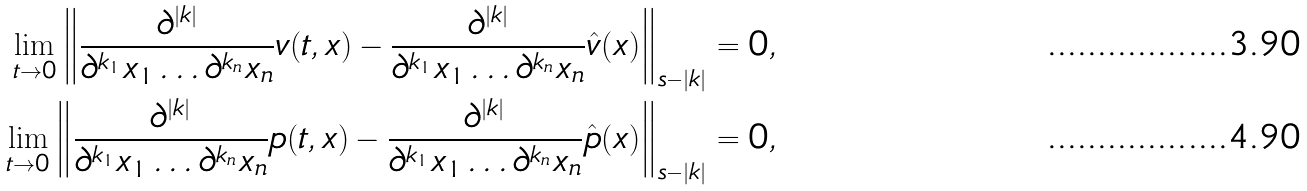Convert formula to latex. <formula><loc_0><loc_0><loc_500><loc_500>\lim _ { t \to 0 } \left \| \frac { \partial ^ { | k | } } { \partial ^ { k _ { 1 } } x _ { 1 } \dots \partial ^ { k _ { n } } x _ { n } } v ( t , x ) - \frac { \partial ^ { | k | } } { \partial ^ { k _ { 1 } } x _ { 1 } \dots \partial ^ { k _ { n } } x _ { n } } \hat { v } ( x ) \right \| _ { s - | k | } & = 0 , \\ \lim _ { t \to 0 } \left \| \frac { \partial ^ { | k | } } { \partial ^ { k _ { 1 } } x _ { 1 } \dots \partial ^ { k _ { n } } x _ { n } } p ( t , x ) - \frac { \partial ^ { | k | } } { \partial ^ { k _ { 1 } } x _ { 1 } \dots \partial ^ { k _ { n } } x _ { n } } \hat { p } ( x ) \right \| _ { s - | k | } & = 0 ,</formula> 